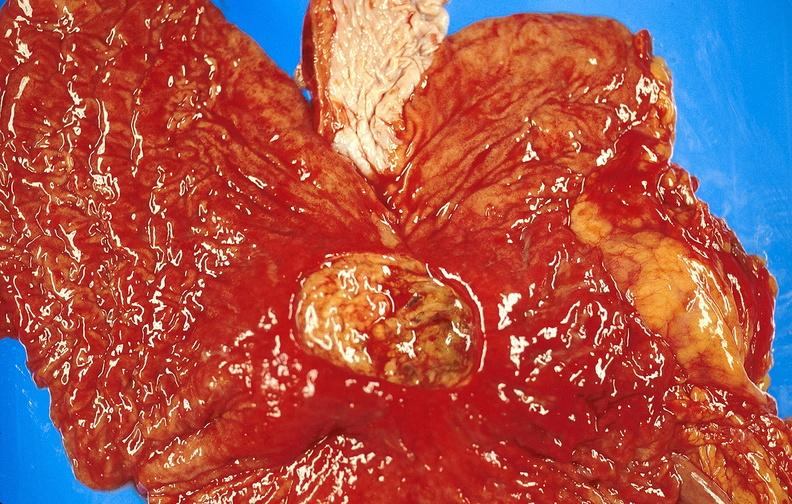does aldehyde fuscin show gastric ulcer?
Answer the question using a single word or phrase. No 